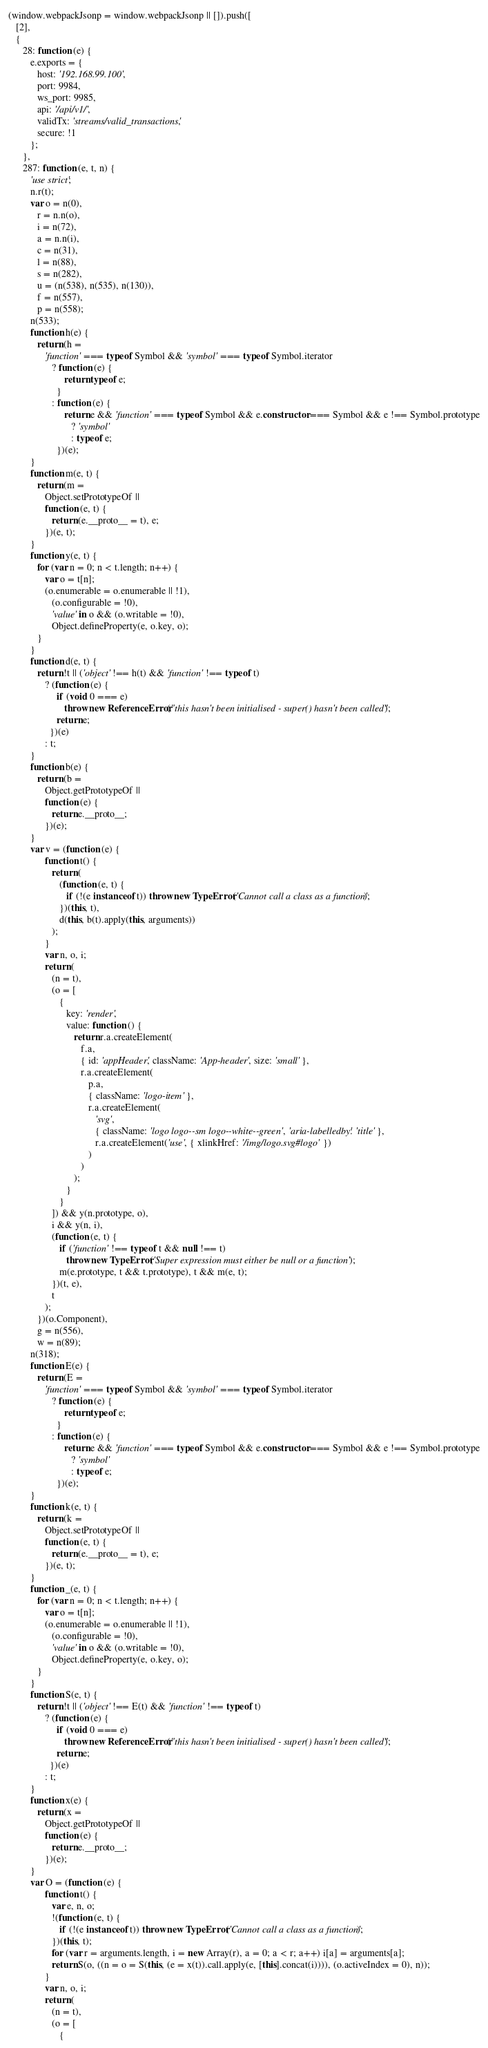<code> <loc_0><loc_0><loc_500><loc_500><_JavaScript_>(window.webpackJsonp = window.webpackJsonp || []).push([
   [2],
   {
      28: function (e) {
         e.exports = {
            host: '192.168.99.100',
            port: 9984,
            ws_port: 9985,
            api: '/api/v1/',
            validTx: 'streams/valid_transactions',
            secure: !1
         };
      },
      287: function (e, t, n) {
         'use strict';
         n.r(t);
         var o = n(0),
            r = n.n(o),
            i = n(72),
            a = n.n(i),
            c = n(31),
            l = n(88),
            s = n(282),
            u = (n(538), n(535), n(130)),
            f = n(557),
            p = n(558);
         n(533);
         function h(e) {
            return (h =
               'function' === typeof Symbol && 'symbol' === typeof Symbol.iterator
                  ? function (e) {
                       return typeof e;
                    }
                  : function (e) {
                       return e && 'function' === typeof Symbol && e.constructor === Symbol && e !== Symbol.prototype
                          ? 'symbol'
                          : typeof e;
                    })(e);
         }
         function m(e, t) {
            return (m =
               Object.setPrototypeOf ||
               function (e, t) {
                  return (e.__proto__ = t), e;
               })(e, t);
         }
         function y(e, t) {
            for (var n = 0; n < t.length; n++) {
               var o = t[n];
               (o.enumerable = o.enumerable || !1),
                  (o.configurable = !0),
                  'value' in o && (o.writable = !0),
                  Object.defineProperty(e, o.key, o);
            }
         }
         function d(e, t) {
            return !t || ('object' !== h(t) && 'function' !== typeof t)
               ? (function (e) {
                    if (void 0 === e)
                       throw new ReferenceError("this hasn't been initialised - super() hasn't been called");
                    return e;
                 })(e)
               : t;
         }
         function b(e) {
            return (b =
               Object.getPrototypeOf ||
               function (e) {
                  return e.__proto__;
               })(e);
         }
         var v = (function (e) {
               function t() {
                  return (
                     (function (e, t) {
                        if (!(e instanceof t)) throw new TypeError('Cannot call a class as a function');
                     })(this, t),
                     d(this, b(t).apply(this, arguments))
                  );
               }
               var n, o, i;
               return (
                  (n = t),
                  (o = [
                     {
                        key: 'render',
                        value: function () {
                           return r.a.createElement(
                              f.a,
                              { id: 'appHeader', className: 'App-header', size: 'small' },
                              r.a.createElement(
                                 p.a,
                                 { className: 'logo-item' },
                                 r.a.createElement(
                                    'svg',
                                    { className: 'logo logo--sm logo--white--green', 'aria-labelledby': 'title' },
                                    r.a.createElement('use', { xlinkHref: '/img/logo.svg#logo' })
                                 )
                              )
                           );
                        }
                     }
                  ]) && y(n.prototype, o),
                  i && y(n, i),
                  (function (e, t) {
                     if ('function' !== typeof t && null !== t)
                        throw new TypeError('Super expression must either be null or a function');
                     m(e.prototype, t && t.prototype), t && m(e, t);
                  })(t, e),
                  t
               );
            })(o.Component),
            g = n(556),
            w = n(89);
         n(318);
         function E(e) {
            return (E =
               'function' === typeof Symbol && 'symbol' === typeof Symbol.iterator
                  ? function (e) {
                       return typeof e;
                    }
                  : function (e) {
                       return e && 'function' === typeof Symbol && e.constructor === Symbol && e !== Symbol.prototype
                          ? 'symbol'
                          : typeof e;
                    })(e);
         }
         function k(e, t) {
            return (k =
               Object.setPrototypeOf ||
               function (e, t) {
                  return (e.__proto__ = t), e;
               })(e, t);
         }
         function _(e, t) {
            for (var n = 0; n < t.length; n++) {
               var o = t[n];
               (o.enumerable = o.enumerable || !1),
                  (o.configurable = !0),
                  'value' in o && (o.writable = !0),
                  Object.defineProperty(e, o.key, o);
            }
         }
         function S(e, t) {
            return !t || ('object' !== E(t) && 'function' !== typeof t)
               ? (function (e) {
                    if (void 0 === e)
                       throw new ReferenceError("this hasn't been initialised - super() hasn't been called");
                    return e;
                 })(e)
               : t;
         }
         function x(e) {
            return (x =
               Object.getPrototypeOf ||
               function (e) {
                  return e.__proto__;
               })(e);
         }
         var O = (function (e) {
               function t() {
                  var e, n, o;
                  !(function (e, t) {
                     if (!(e instanceof t)) throw new TypeError('Cannot call a class as a function');
                  })(this, t);
                  for (var r = arguments.length, i = new Array(r), a = 0; a < r; a++) i[a] = arguments[a];
                  return S(o, ((n = o = S(this, (e = x(t)).call.apply(e, [this].concat(i)))), (o.activeIndex = 0), n));
               }
               var n, o, i;
               return (
                  (n = t),
                  (o = [
                     {</code> 